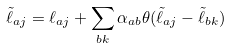Convert formula to latex. <formula><loc_0><loc_0><loc_500><loc_500>\tilde { \ell } _ { a j } = \ell _ { a j } + \sum _ { b k } \alpha _ { a b } \theta ( \tilde { \ell } _ { a j } - \tilde { \ell } _ { b k } ) \,</formula> 